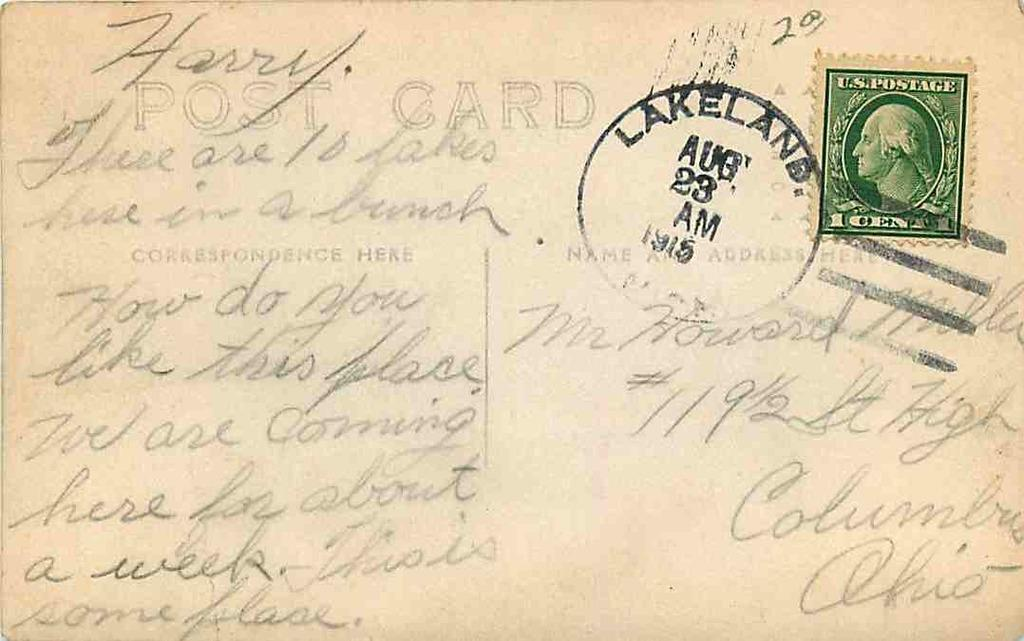<image>
Provide a brief description of the given image. The letter was addressed to a man called,Harry. 